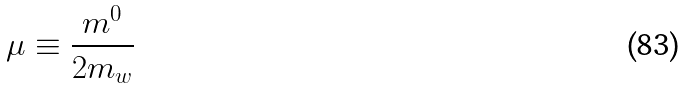Convert formula to latex. <formula><loc_0><loc_0><loc_500><loc_500>\mu \equiv \frac { m ^ { 0 } } { 2 m _ { w } }</formula> 